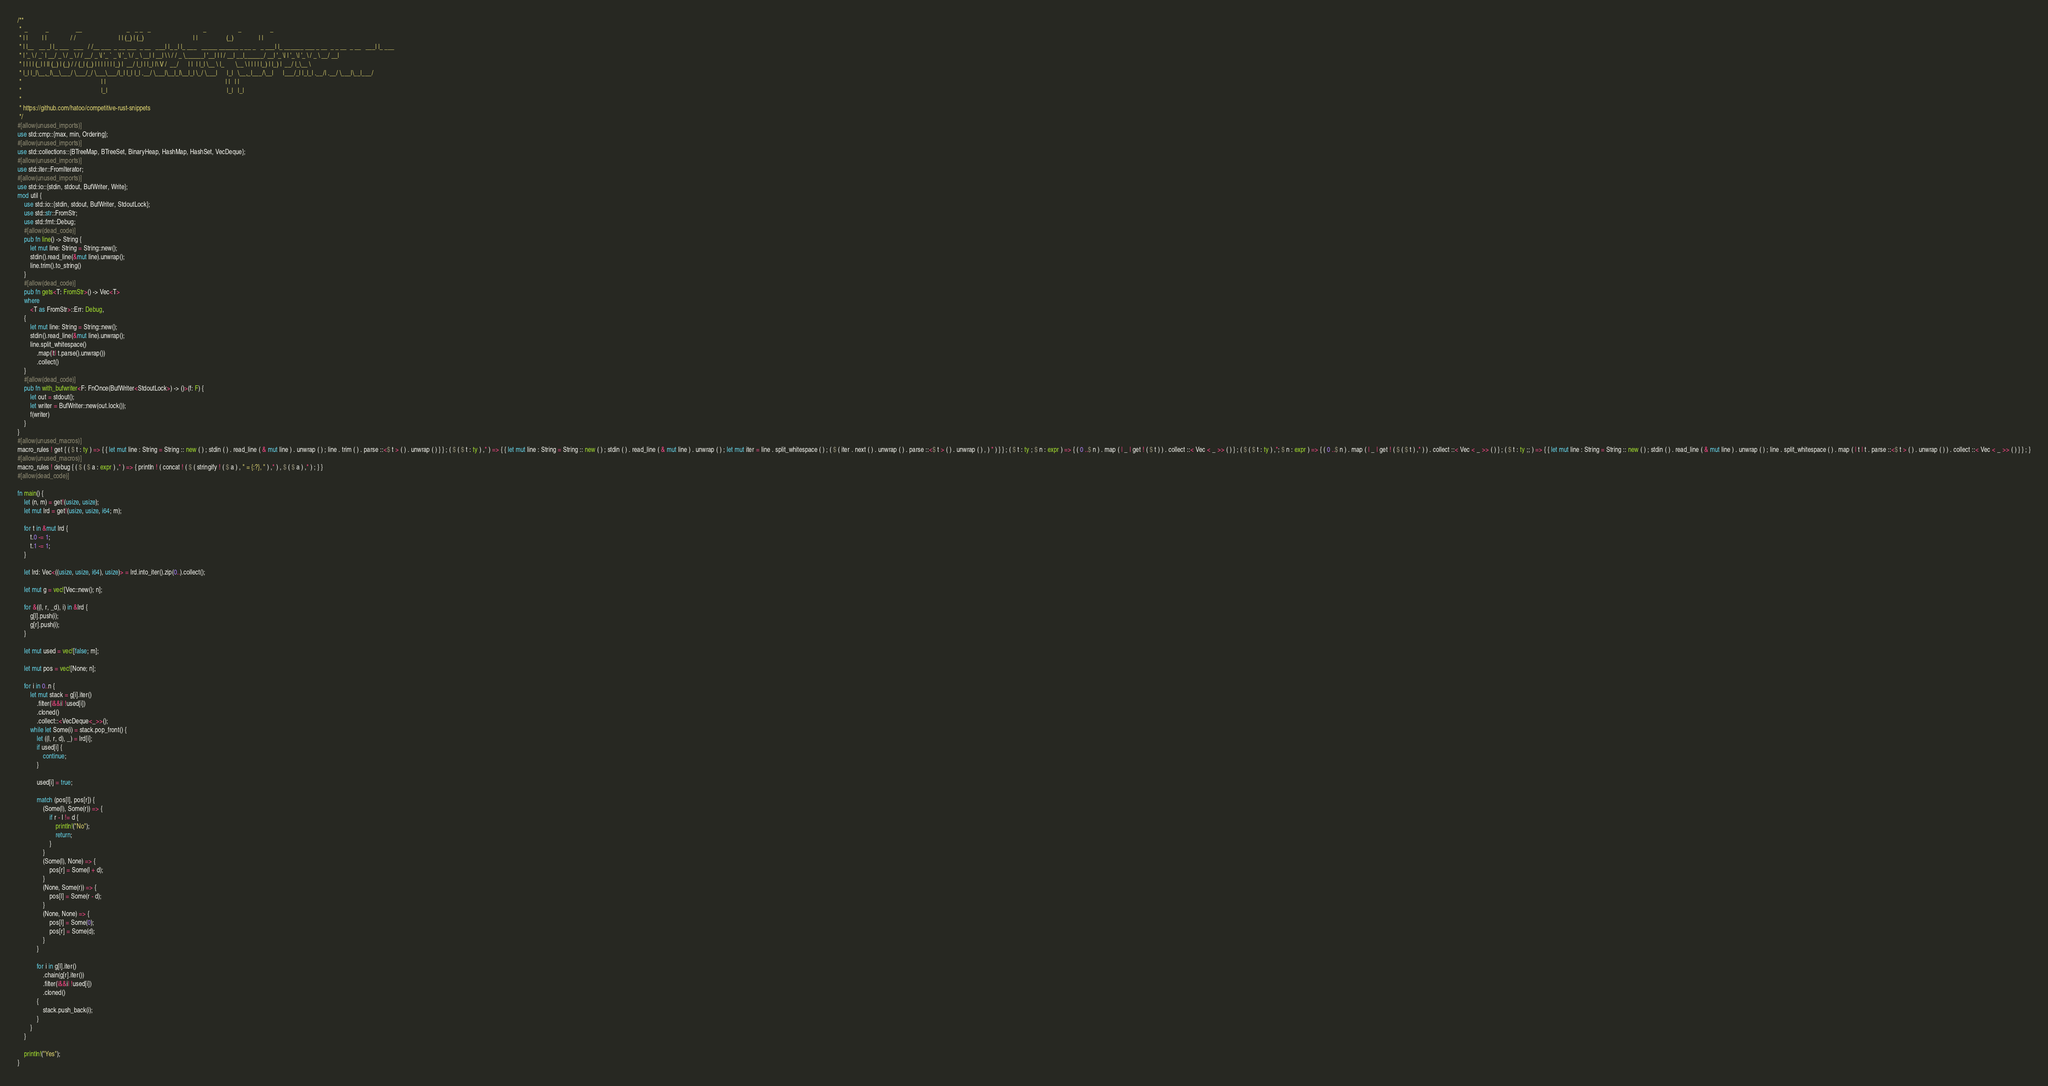Convert code to text. <code><loc_0><loc_0><loc_500><loc_500><_Rust_>/**
 *  _           _                 __                            _   _ _   _                                 _                    _                  _
 * | |         | |               / /                           | | (_) | (_)                               | |                  (_)                | |
 * | |__   __ _| |_ ___   ___   / /__ ___  _ __ ___  _ __   ___| |_ _| |_ ___   _____ ______ _ __ _   _ ___| |_ ______ ___ _ __  _ _ __  _ __   ___| |_ ___
 * | '_ \ / _` | __/ _ \ / _ \ / / __/ _ \| '_ ` _ \| '_ \ / _ \ __| | __| \ \ / / _ \______| '__| | | / __| __|______/ __| '_ \| | '_ \| '_ \ / _ \ __/ __|
 * | | | | (_| | || (_) | (_) / / (_| (_) | | | | | | |_) |  __/ |_| | |_| |\ V /  __/      | |  | |_| \__ \ |_       \__ \ | | | | |_) | |_) |  __/ |_\__ \
 * |_| |_|\__,_|\__\___/ \___/_/ \___\___/|_| |_| |_| .__/ \___|\__|_|\__|_| \_/ \___|      |_|   \__,_|___/\__|      |___/_| |_|_| .__/| .__/ \___|\__|___/
 *                                                  | |                                                                           | |   | |
 *                                                  |_|                                                                           |_|   |_|
 *
 * https://github.com/hatoo/competitive-rust-snippets
 */
#[allow(unused_imports)]
use std::cmp::{max, min, Ordering};
#[allow(unused_imports)]
use std::collections::{BTreeMap, BTreeSet, BinaryHeap, HashMap, HashSet, VecDeque};
#[allow(unused_imports)]
use std::iter::FromIterator;
#[allow(unused_imports)]
use std::io::{stdin, stdout, BufWriter, Write};
mod util {
    use std::io::{stdin, stdout, BufWriter, StdoutLock};
    use std::str::FromStr;
    use std::fmt::Debug;
    #[allow(dead_code)]
    pub fn line() -> String {
        let mut line: String = String::new();
        stdin().read_line(&mut line).unwrap();
        line.trim().to_string()
    }
    #[allow(dead_code)]
    pub fn gets<T: FromStr>() -> Vec<T>
    where
        <T as FromStr>::Err: Debug,
    {
        let mut line: String = String::new();
        stdin().read_line(&mut line).unwrap();
        line.split_whitespace()
            .map(|t| t.parse().unwrap())
            .collect()
    }
    #[allow(dead_code)]
    pub fn with_bufwriter<F: FnOnce(BufWriter<StdoutLock>) -> ()>(f: F) {
        let out = stdout();
        let writer = BufWriter::new(out.lock());
        f(writer)
    }
}
#[allow(unused_macros)]
macro_rules ! get { ( $ t : ty ) => { { let mut line : String = String :: new ( ) ; stdin ( ) . read_line ( & mut line ) . unwrap ( ) ; line . trim ( ) . parse ::<$ t > ( ) . unwrap ( ) } } ; ( $ ( $ t : ty ) ,* ) => { { let mut line : String = String :: new ( ) ; stdin ( ) . read_line ( & mut line ) . unwrap ( ) ; let mut iter = line . split_whitespace ( ) ; ( $ ( iter . next ( ) . unwrap ( ) . parse ::<$ t > ( ) . unwrap ( ) , ) * ) } } ; ( $ t : ty ; $ n : expr ) => { ( 0 ..$ n ) . map ( | _ | get ! ( $ t ) ) . collect ::< Vec < _ >> ( ) } ; ( $ ( $ t : ty ) ,*; $ n : expr ) => { ( 0 ..$ n ) . map ( | _ | get ! ( $ ( $ t ) ,* ) ) . collect ::< Vec < _ >> ( ) } ; ( $ t : ty ;; ) => { { let mut line : String = String :: new ( ) ; stdin ( ) . read_line ( & mut line ) . unwrap ( ) ; line . split_whitespace ( ) . map ( | t | t . parse ::<$ t > ( ) . unwrap ( ) ) . collect ::< Vec < _ >> ( ) } } ; }
#[allow(unused_macros)]
macro_rules ! debug { ( $ ( $ a : expr ) ,* ) => { println ! ( concat ! ( $ ( stringify ! ( $ a ) , " = {:?}, " ) ,* ) , $ ( $ a ) ,* ) ; } }
#[allow(dead_code)]

fn main() {
    let (n, m) = get!(usize, usize);
    let mut lrd = get!(usize, usize, i64; m);

    for t in &mut lrd {
        t.0 -= 1;
        t.1 -= 1;
    }

    let lrd: Vec<((usize, usize, i64), usize)> = lrd.into_iter().zip(0..).collect();

    let mut g = vec![Vec::new(); n];

    for &((l, r, _d), i) in &lrd {
        g[l].push(i);
        g[r].push(i);
    }

    let mut used = vec![false; m];

    let mut pos = vec![None; n];

    for i in 0..n {
        let mut stack = g[i].iter()
            .filter(|&&i| !used[i])
            .cloned()
            .collect::<VecDeque<_>>();
        while let Some(i) = stack.pop_front() {
            let ((l, r, d), _) = lrd[i];
            if used[i] {
                continue;
            }

            used[i] = true;

            match (pos[l], pos[r]) {
                (Some(l), Some(r)) => {
                    if r - l != d {
                        println!("No");
                        return;
                    }
                }
                (Some(l), None) => {
                    pos[r] = Some(l + d);
                }
                (None, Some(r)) => {
                    pos[l] = Some(r - d);
                }
                (None, None) => {
                    pos[l] = Some(0);
                    pos[r] = Some(d);
                }
            }

            for i in g[l].iter()
                .chain(g[r].iter())
                .filter(|&&i| !used[i])
                .cloned()
            {
                stack.push_back(i);
            }
        }
    }

    println!("Yes");
}
</code> 